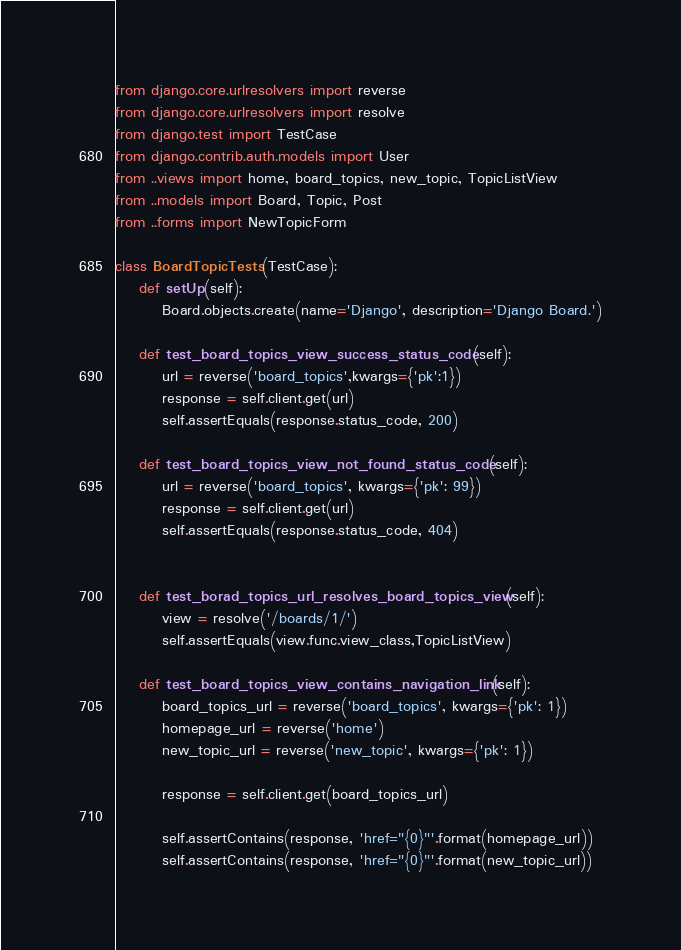<code> <loc_0><loc_0><loc_500><loc_500><_Python_>from django.core.urlresolvers import reverse
from django.core.urlresolvers import resolve
from django.test import TestCase
from django.contrib.auth.models import User
from ..views import home, board_topics, new_topic, TopicListView
from ..models import Board, Topic, Post
from ..forms import NewTopicForm

class BoardTopicTests(TestCase):
    def setUp(self):
        Board.objects.create(name='Django', description='Django Board.')

    def test_board_topics_view_success_status_code(self):
        url = reverse('board_topics',kwargs={'pk':1})
        response = self.client.get(url)
        self.assertEquals(response.status_code, 200)

    def test_board_topics_view_not_found_status_code(self):
        url = reverse('board_topics', kwargs={'pk': 99})
        response = self.client.get(url)
        self.assertEquals(response.status_code, 404)


    def test_borad_topics_url_resolves_board_topics_view(self):
        view = resolve('/boards/1/')
        self.assertEquals(view.func.view_class,TopicListView)

    def test_board_topics_view_contains_navigation_link(self):
        board_topics_url = reverse('board_topics', kwargs={'pk': 1})
        homepage_url = reverse('home')
        new_topic_url = reverse('new_topic', kwargs={'pk': 1})

        response = self.client.get(board_topics_url)

        self.assertContains(response, 'href="{0}"'.format(homepage_url))
        self.assertContains(response, 'href="{0}"'.format(new_topic_url))</code> 